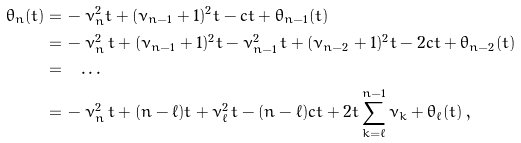<formula> <loc_0><loc_0><loc_500><loc_500>\theta _ { n } ( t ) = & \, - \nu _ { n } ^ { 2 } t + ( \nu _ { n - 1 } + 1 ) ^ { 2 } t - c t + \theta _ { n - 1 } ( t ) \\ = & \, - \nu _ { n } ^ { 2 } \, t + ( \nu _ { n - 1 } + 1 ) ^ { 2 } t - \nu _ { n - 1 } ^ { 2 } \, t + ( \nu _ { n - 2 } + 1 ) ^ { 2 } t - 2 c t + \theta _ { n - 2 } ( t ) \\ = & \quad \dots \\ = & \, - \nu _ { n } ^ { 2 } \, t + ( n - \ell ) t + \nu _ { \ell } ^ { 2 } \, t - ( n - \ell ) c t + 2 t \sum _ { k = \ell } ^ { n - 1 } \nu _ { k } + \theta _ { \ell } ( t ) \, ,</formula> 